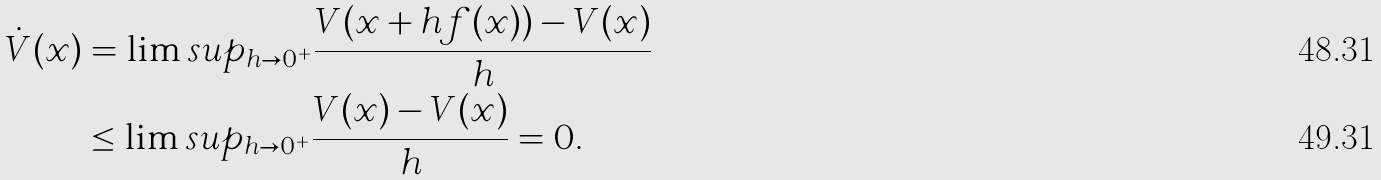<formula> <loc_0><loc_0><loc_500><loc_500>\dot { V } ( x ) & = \lim s u p _ { h \to 0 ^ { + } } \frac { V ( x + h f ( x ) ) - V ( x ) } { h } \\ & \leq \lim s u p _ { h \to 0 ^ { + } } \frac { V ( x ) - V ( x ) } { h } = 0 .</formula> 